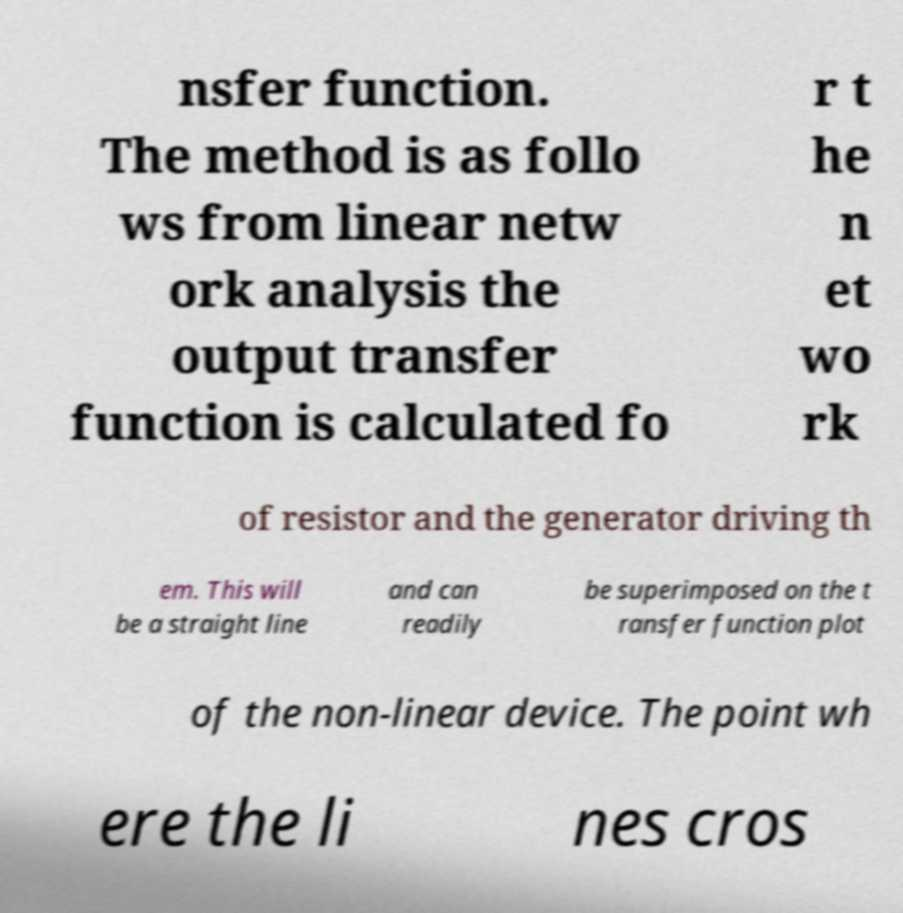For documentation purposes, I need the text within this image transcribed. Could you provide that? nsfer function. The method is as follo ws from linear netw ork analysis the output transfer function is calculated fo r t he n et wo rk of resistor and the generator driving th em. This will be a straight line and can readily be superimposed on the t ransfer function plot of the non-linear device. The point wh ere the li nes cros 